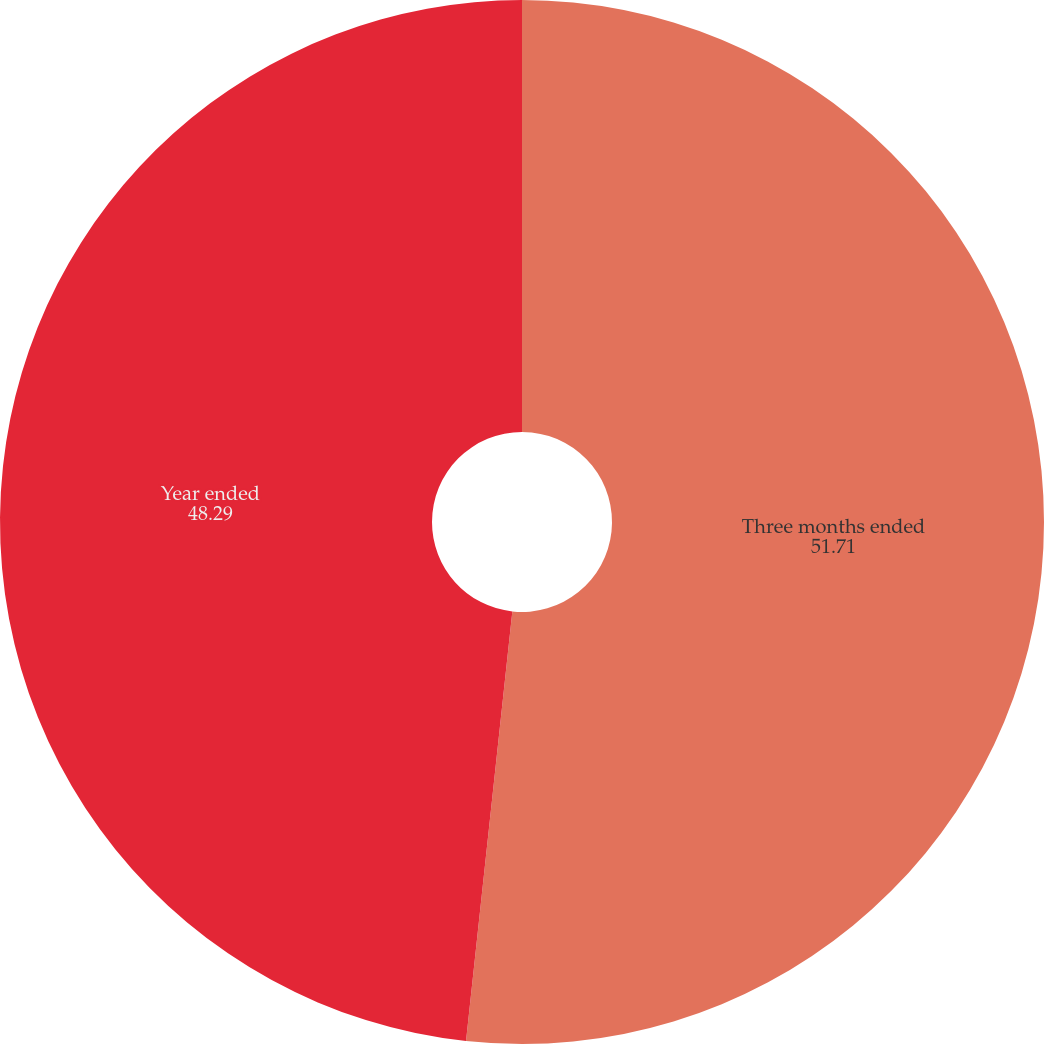Convert chart to OTSL. <chart><loc_0><loc_0><loc_500><loc_500><pie_chart><fcel>Three months ended<fcel>Year ended<nl><fcel>51.71%<fcel>48.29%<nl></chart> 